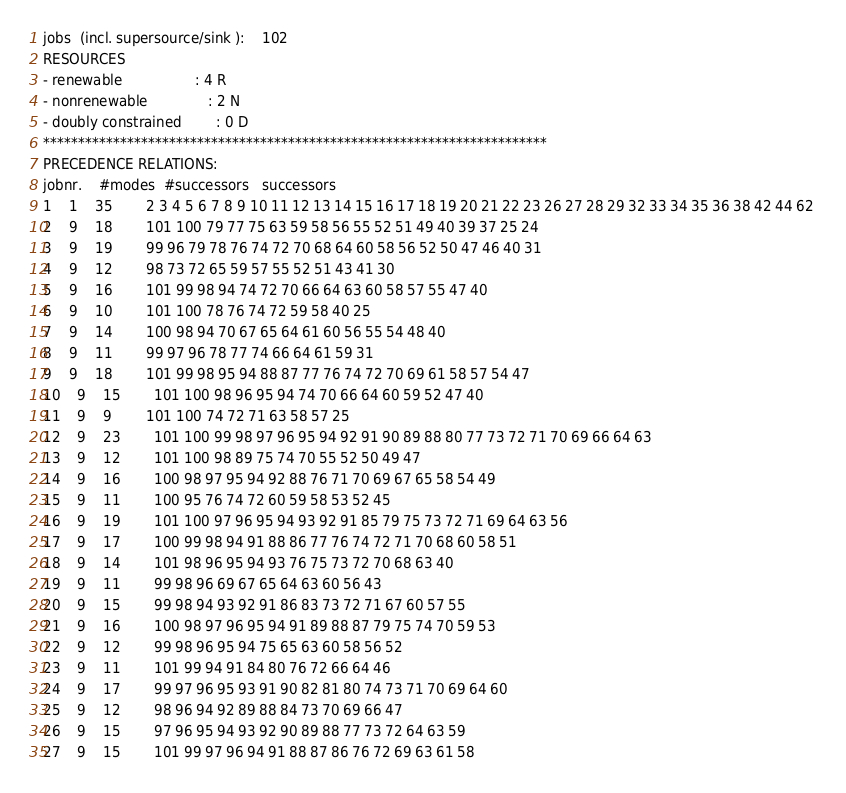Convert code to text. <code><loc_0><loc_0><loc_500><loc_500><_ObjectiveC_>jobs  (incl. supersource/sink ):	102
RESOURCES
- renewable                 : 4 R
- nonrenewable              : 2 N
- doubly constrained        : 0 D
************************************************************************
PRECEDENCE RELATIONS:
jobnr.    #modes  #successors   successors
1	1	35		2 3 4 5 6 7 8 9 10 11 12 13 14 15 16 17 18 19 20 21 22 23 26 27 28 29 32 33 34 35 36 38 42 44 62 
2	9	18		101 100 79 77 75 63 59 58 56 55 52 51 49 40 39 37 25 24 
3	9	19		99 96 79 78 76 74 72 70 68 64 60 58 56 52 50 47 46 40 31 
4	9	12		98 73 72 65 59 57 55 52 51 43 41 30 
5	9	16		101 99 98 94 74 72 70 66 64 63 60 58 57 55 47 40 
6	9	10		101 100 78 76 74 72 59 58 40 25 
7	9	14		100 98 94 70 67 65 64 61 60 56 55 54 48 40 
8	9	11		99 97 96 78 77 74 66 64 61 59 31 
9	9	18		101 99 98 95 94 88 87 77 76 74 72 70 69 61 58 57 54 47 
10	9	15		101 100 98 96 95 94 74 70 66 64 60 59 52 47 40 
11	9	9		101 100 74 72 71 63 58 57 25 
12	9	23		101 100 99 98 97 96 95 94 92 91 90 89 88 80 77 73 72 71 70 69 66 64 63 
13	9	12		101 100 98 89 75 74 70 55 52 50 49 47 
14	9	16		100 98 97 95 94 92 88 76 71 70 69 67 65 58 54 49 
15	9	11		100 95 76 74 72 60 59 58 53 52 45 
16	9	19		101 100 97 96 95 94 93 92 91 85 79 75 73 72 71 69 64 63 56 
17	9	17		100 99 98 94 91 88 86 77 76 74 72 71 70 68 60 58 51 
18	9	14		101 98 96 95 94 93 76 75 73 72 70 68 63 40 
19	9	11		99 98 96 69 67 65 64 63 60 56 43 
20	9	15		99 98 94 93 92 91 86 83 73 72 71 67 60 57 55 
21	9	16		100 98 97 96 95 94 91 89 88 87 79 75 74 70 59 53 
22	9	12		99 98 96 95 94 75 65 63 60 58 56 52 
23	9	11		101 99 94 91 84 80 76 72 66 64 46 
24	9	17		99 97 96 95 93 91 90 82 81 80 74 73 71 70 69 64 60 
25	9	12		98 96 94 92 89 88 84 73 70 69 66 47 
26	9	15		97 96 95 94 93 92 90 89 88 77 73 72 64 63 59 
27	9	15		101 99 97 96 94 91 88 87 86 76 72 69 63 61 58 </code> 